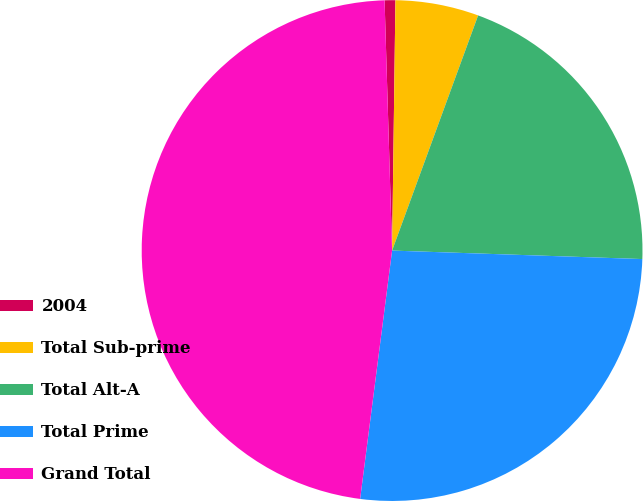Convert chart to OTSL. <chart><loc_0><loc_0><loc_500><loc_500><pie_chart><fcel>2004<fcel>Total Sub-prime<fcel>Total Alt-A<fcel>Total Prime<fcel>Grand Total<nl><fcel>0.69%<fcel>5.37%<fcel>19.96%<fcel>26.5%<fcel>47.49%<nl></chart> 